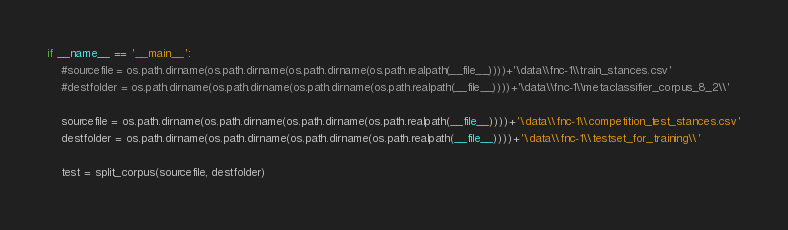<code> <loc_0><loc_0><loc_500><loc_500><_Python_>
if __name__ == '__main__':
    #sourcefile = os.path.dirname(os.path.dirname(os.path.dirname(os.path.realpath(__file__))))+'\data\\fnc-1\\train_stances.csv'
    #destfolder = os.path.dirname(os.path.dirname(os.path.dirname(os.path.realpath(__file__))))+'\data\\fnc-1\\metaclassifier_corpus_8_2\\'

    sourcefile = os.path.dirname(os.path.dirname(os.path.dirname(os.path.realpath(__file__))))+'\data\\fnc-1\\competition_test_stances.csv'
    destfolder = os.path.dirname(os.path.dirname(os.path.dirname(os.path.realpath(__file__))))+'\data\\fnc-1\\testset_for_training\\'

    test = split_corpus(sourcefile, destfolder)

</code> 